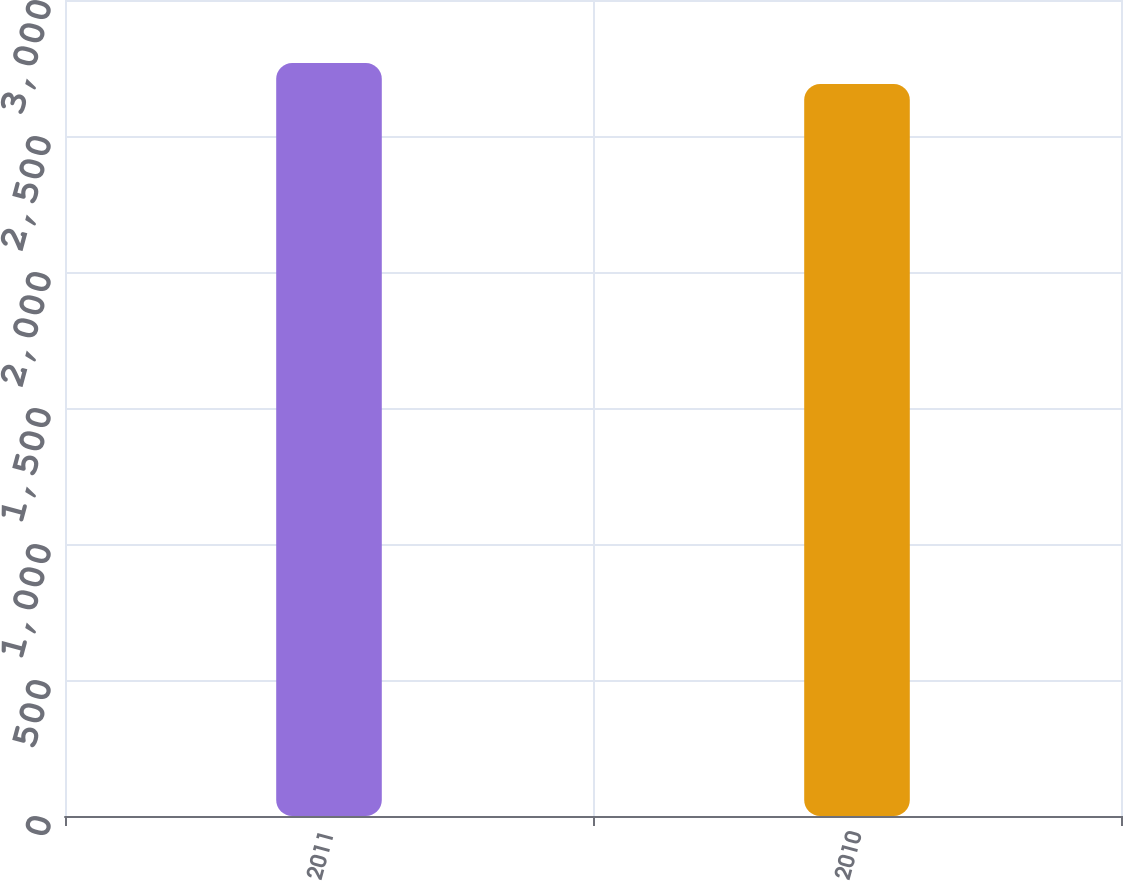Convert chart. <chart><loc_0><loc_0><loc_500><loc_500><bar_chart><fcel>2011<fcel>2010<nl><fcel>2768<fcel>2691<nl></chart> 